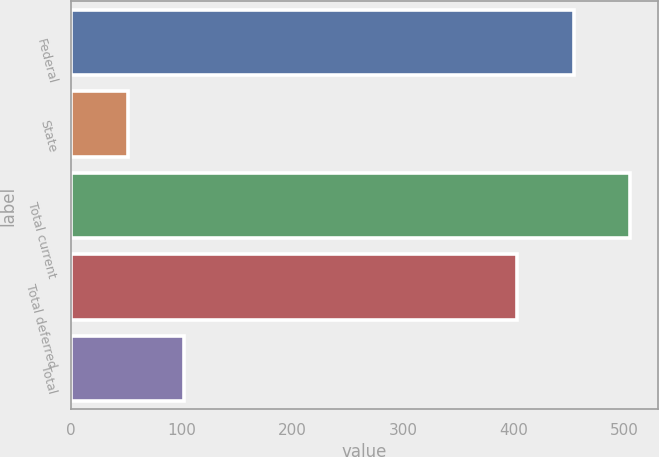Convert chart to OTSL. <chart><loc_0><loc_0><loc_500><loc_500><bar_chart><fcel>Federal<fcel>State<fcel>Total current<fcel>Total deferred<fcel>Total<nl><fcel>454<fcel>51<fcel>505<fcel>403<fcel>102<nl></chart> 